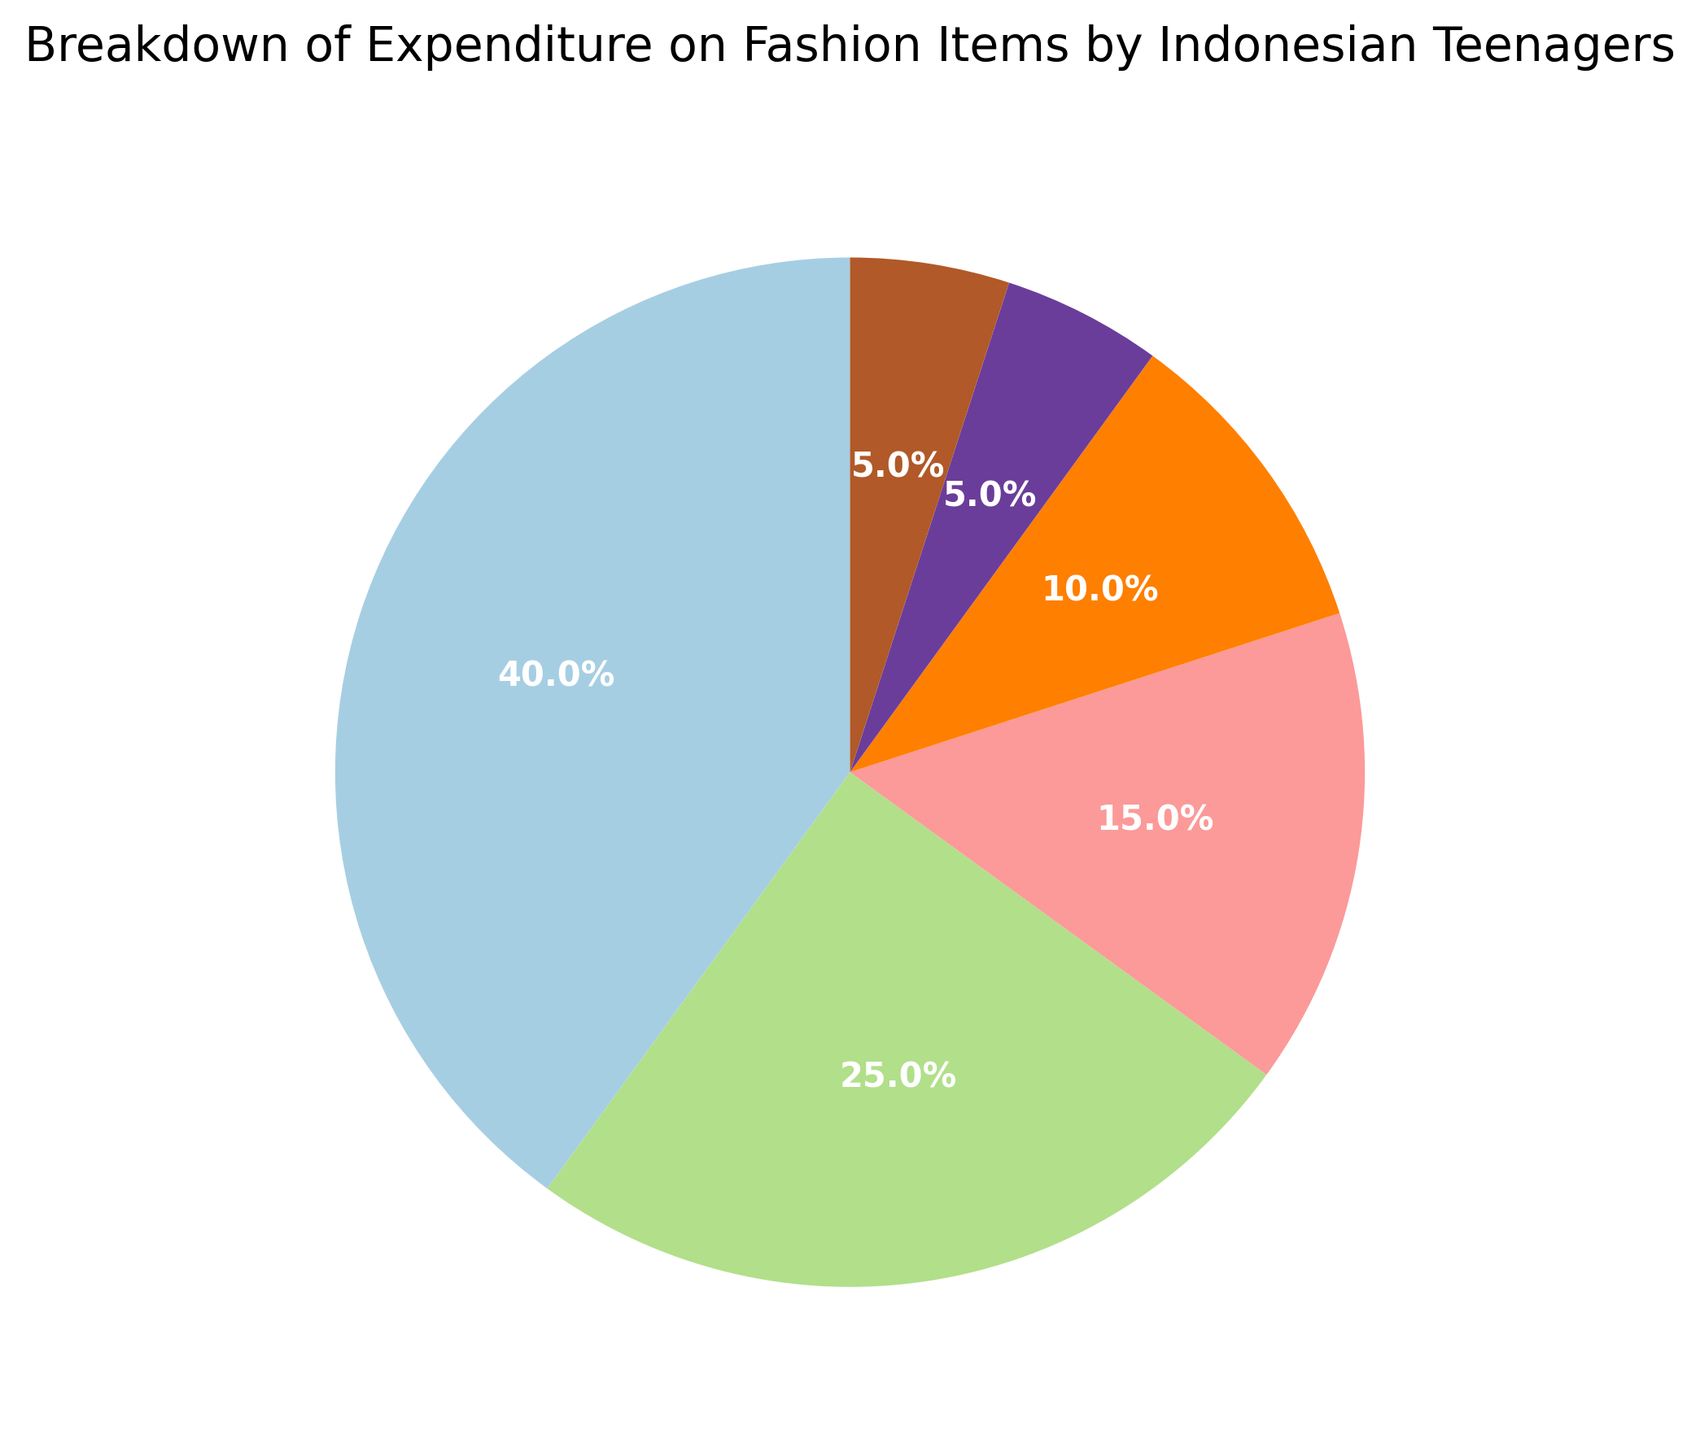Which category has the highest expenditure percentage? By looking at the largest section of the pie chart, we can see that Clothing has the largest slice, which means it has the highest expenditure percentage.
Answer: Clothing Which category has the lowest expenditure percentage? By looking at the smallest section of the pie chart, we can see that Cosmetics and Others both have the smallest slices, meaning they tie for the lowest expenditure percentage.
Answer: Cosmetics and Others How much higher is the expenditure percentage on Clothing compared to Shoes? By comparing the percentage of Clothing (40%) to Shoes (25%), we find the difference: 40% - 25% = 15%.
Answer: 15% What is the combined expenditure percentage of Accessories and Bags? Combined expenditure percentage is found by adding Accessories (15%) and Bags (10%): 15% + 10% = 25%.
Answer: 25% Are there any categories where the expenditure percentages are equal? By looking at the pie chart and the slices representing each category, we can see that Cosmetics and Others both have a 5% expenditure percentage, making them equal.
Answer: Yes, Cosmetics and Others What percentage of expenditure is allocated to items other than Clothing? We calculate this by subtracting the percentage of Clothing from 100%: 100% - 40% = 60%.
Answer: 60% How does the expenditure on Shoes compare to the expenditure on Bags? The percentage for Shoes (25%) is higher than that for Bags (10%).
Answer: Shoes have a higher expenditure than Bags What proportion of the total expenditure is dedicated to non-essential items like Accessories, Bags, and Cosmetics? We sum up the percentages for Accessories (15%), Bags (10%), and Cosmetics (5%): 15% + 10% + 5% = 30%.
Answer: 30% If you combine the expenditure percentages on Clothing, Shoes, and Accessories, what do you get? We sum up the percentages for Clothing (40%), Shoes (25%), and Accessories (15%): 40% + 25% + 15% = 80%.
Answer: 80% Are Bags and Cosmetics combined bigger in expenditure percentage than Accessories alone? By summing Bags (10%) and Cosmetics (5%), we get 10% + 5% = 15%. This is equal to the Accessories expenditure percentage (15%).
Answer: No, they are equal 